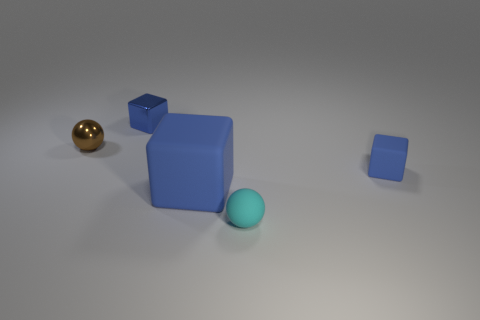Subtract all blue cubes. How many were subtracted if there are1blue cubes left? 2 Subtract all small metal blocks. How many blocks are left? 2 Add 2 large red rubber objects. How many objects exist? 7 Subtract all gray blocks. Subtract all brown balls. How many blocks are left? 3 Subtract all spheres. How many objects are left? 3 Add 5 small brown objects. How many small brown objects are left? 6 Add 4 shiny things. How many shiny things exist? 6 Subtract 0 yellow spheres. How many objects are left? 5 Subtract all small cylinders. Subtract all large blue cubes. How many objects are left? 4 